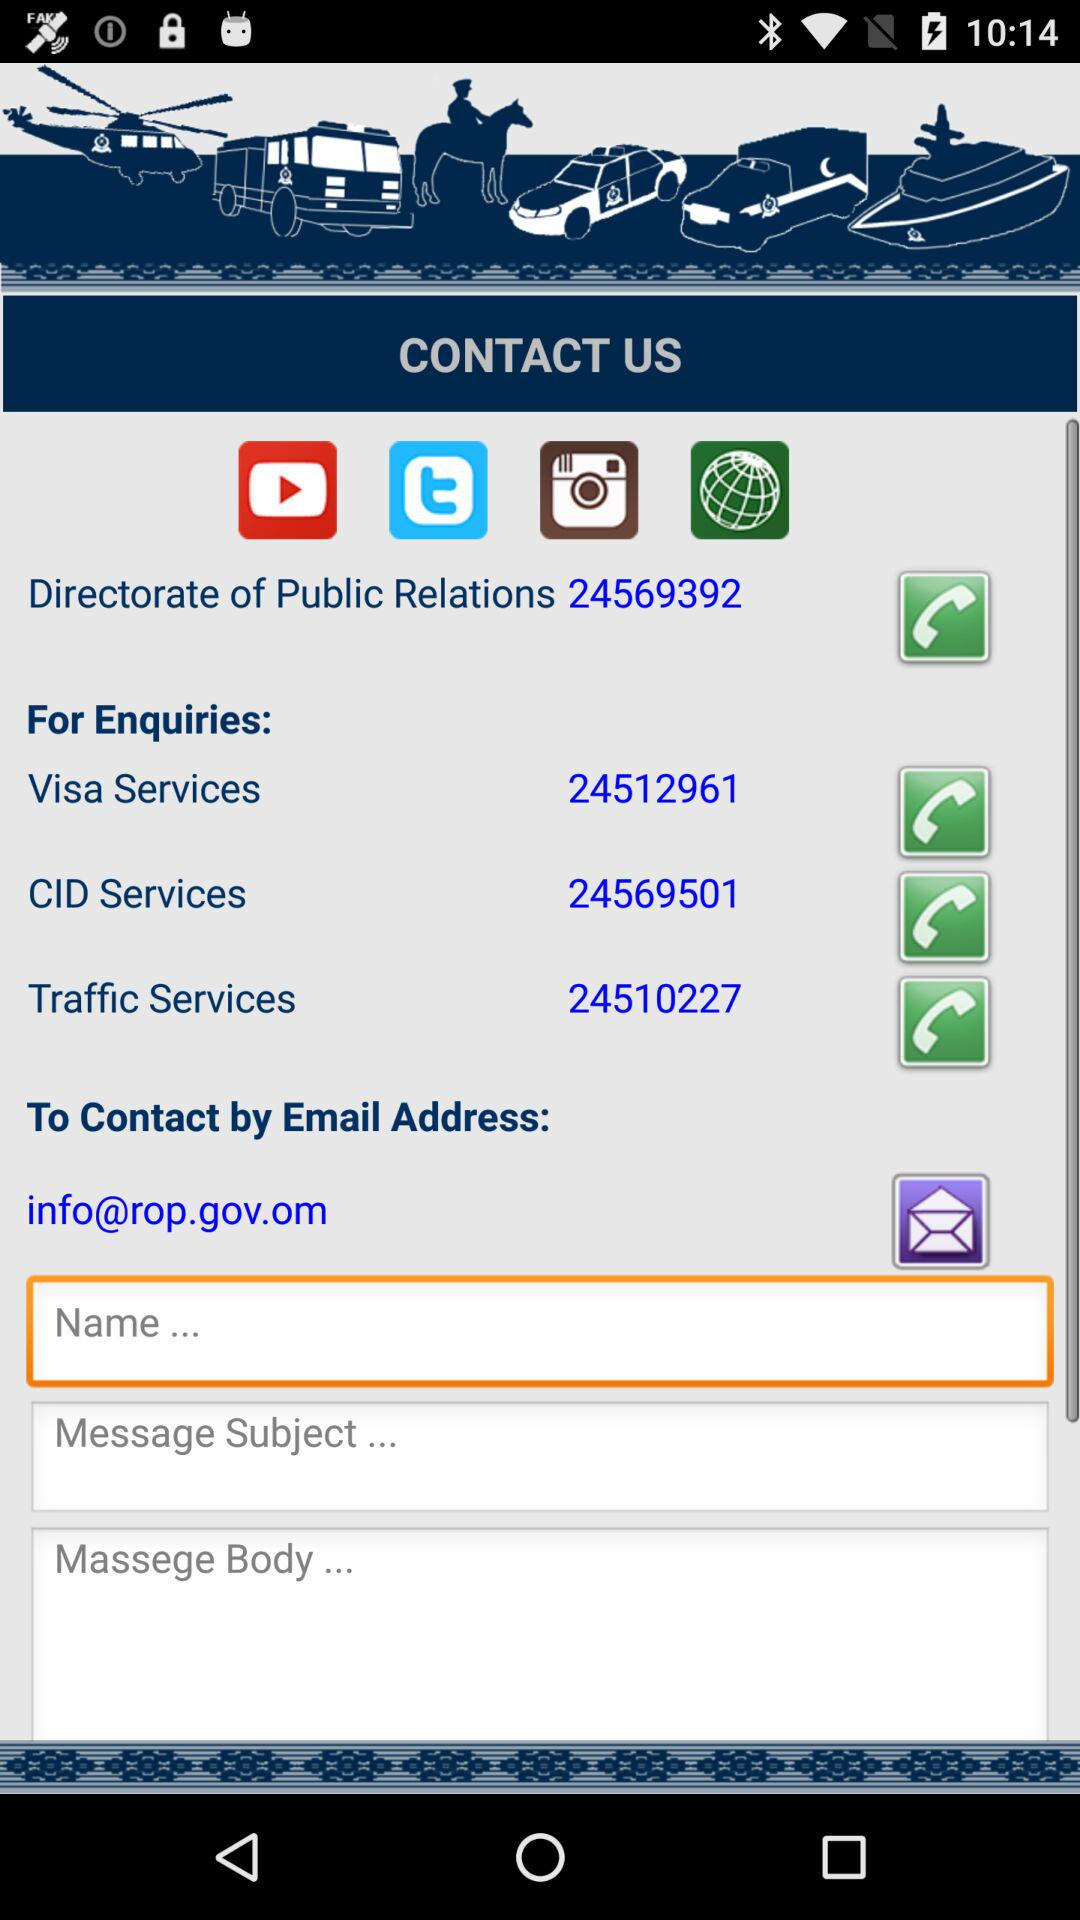What is the contact number of the "Directorate of Public Relations"? The contact number is 24569392. 